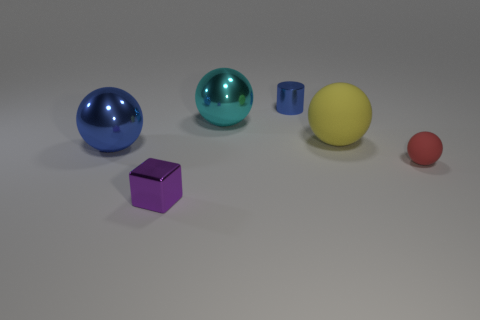Add 2 large red metal balls. How many objects exist? 8 Subtract all blocks. How many objects are left? 5 Add 1 small red balls. How many small red balls exist? 2 Subtract 0 green balls. How many objects are left? 6 Subtract all large cyan spheres. Subtract all cyan matte objects. How many objects are left? 5 Add 5 tiny metal things. How many tiny metal things are left? 7 